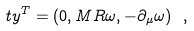<formula> <loc_0><loc_0><loc_500><loc_500>\ t y ^ { T } = ( 0 , M R \omega , - \partial _ { \mu } \omega ) \ ,</formula> 